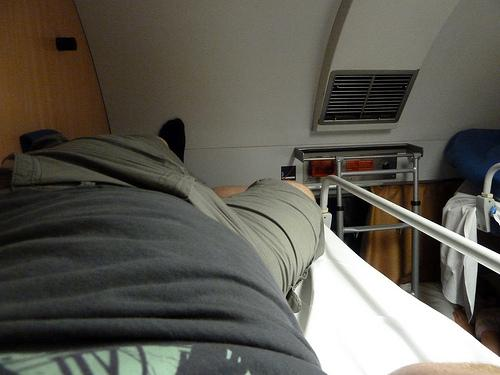Question: what is the main focus of this photo?
Choices:
A. Trophy.
B. Surfer.
C. Lower half of a person's body.
D. Race horses.
Answer with the letter. Answer: C Question: when was this photo taken?
Choices:
A. Inside a room.
B. Before dawn.
C. At the baptism.
D. Lunch time.
Answer with the letter. Answer: A 